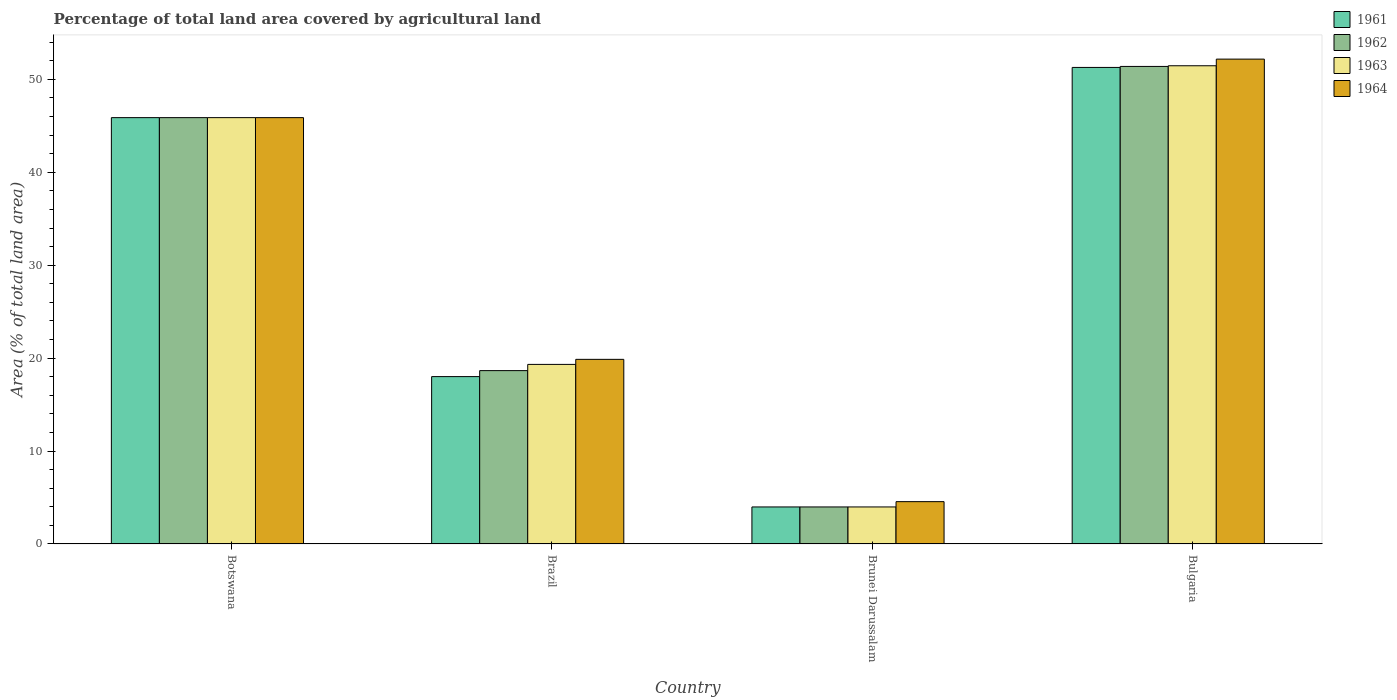Are the number of bars on each tick of the X-axis equal?
Your answer should be compact. Yes. How many bars are there on the 4th tick from the left?
Your answer should be very brief. 4. What is the label of the 3rd group of bars from the left?
Make the answer very short. Brunei Darussalam. What is the percentage of agricultural land in 1962 in Botswana?
Ensure brevity in your answer.  45.88. Across all countries, what is the maximum percentage of agricultural land in 1964?
Ensure brevity in your answer.  52.17. Across all countries, what is the minimum percentage of agricultural land in 1962?
Provide a short and direct response. 3.98. In which country was the percentage of agricultural land in 1961 maximum?
Your response must be concise. Bulgaria. In which country was the percentage of agricultural land in 1962 minimum?
Keep it short and to the point. Brunei Darussalam. What is the total percentage of agricultural land in 1962 in the graph?
Your answer should be compact. 119.9. What is the difference between the percentage of agricultural land in 1964 in Brazil and that in Bulgaria?
Offer a very short reply. -32.31. What is the difference between the percentage of agricultural land in 1964 in Botswana and the percentage of agricultural land in 1963 in Brunei Darussalam?
Offer a very short reply. 41.89. What is the average percentage of agricultural land in 1963 per country?
Your response must be concise. 30.16. What is the difference between the percentage of agricultural land of/in 1964 and percentage of agricultural land of/in 1963 in Bulgaria?
Provide a succinct answer. 0.71. What is the ratio of the percentage of agricultural land in 1963 in Brazil to that in Bulgaria?
Make the answer very short. 0.38. What is the difference between the highest and the second highest percentage of agricultural land in 1961?
Your response must be concise. -33.27. What is the difference between the highest and the lowest percentage of agricultural land in 1963?
Provide a succinct answer. 47.48. Is the sum of the percentage of agricultural land in 1963 in Botswana and Brazil greater than the maximum percentage of agricultural land in 1962 across all countries?
Provide a succinct answer. Yes. What does the 2nd bar from the right in Bulgaria represents?
Your answer should be compact. 1963. How many countries are there in the graph?
Give a very brief answer. 4. What is the difference between two consecutive major ticks on the Y-axis?
Your response must be concise. 10. Does the graph contain any zero values?
Offer a very short reply. No. Does the graph contain grids?
Provide a succinct answer. No. Where does the legend appear in the graph?
Offer a very short reply. Top right. How many legend labels are there?
Provide a short and direct response. 4. How are the legend labels stacked?
Offer a very short reply. Vertical. What is the title of the graph?
Provide a short and direct response. Percentage of total land area covered by agricultural land. Does "2012" appear as one of the legend labels in the graph?
Provide a short and direct response. No. What is the label or title of the X-axis?
Provide a short and direct response. Country. What is the label or title of the Y-axis?
Your answer should be very brief. Area (% of total land area). What is the Area (% of total land area) in 1961 in Botswana?
Make the answer very short. 45.88. What is the Area (% of total land area) of 1962 in Botswana?
Provide a succinct answer. 45.88. What is the Area (% of total land area) of 1963 in Botswana?
Make the answer very short. 45.88. What is the Area (% of total land area) in 1964 in Botswana?
Provide a short and direct response. 45.88. What is the Area (% of total land area) of 1961 in Brazil?
Give a very brief answer. 18.01. What is the Area (% of total land area) in 1962 in Brazil?
Make the answer very short. 18.65. What is the Area (% of total land area) of 1963 in Brazil?
Provide a short and direct response. 19.32. What is the Area (% of total land area) in 1964 in Brazil?
Your answer should be compact. 19.87. What is the Area (% of total land area) in 1961 in Brunei Darussalam?
Provide a short and direct response. 3.98. What is the Area (% of total land area) of 1962 in Brunei Darussalam?
Give a very brief answer. 3.98. What is the Area (% of total land area) in 1963 in Brunei Darussalam?
Your answer should be very brief. 3.98. What is the Area (% of total land area) of 1964 in Brunei Darussalam?
Your answer should be compact. 4.55. What is the Area (% of total land area) in 1961 in Bulgaria?
Give a very brief answer. 51.28. What is the Area (% of total land area) in 1962 in Bulgaria?
Offer a very short reply. 51.39. What is the Area (% of total land area) in 1963 in Bulgaria?
Offer a very short reply. 51.46. What is the Area (% of total land area) in 1964 in Bulgaria?
Ensure brevity in your answer.  52.17. Across all countries, what is the maximum Area (% of total land area) of 1961?
Ensure brevity in your answer.  51.28. Across all countries, what is the maximum Area (% of total land area) in 1962?
Offer a very short reply. 51.39. Across all countries, what is the maximum Area (% of total land area) of 1963?
Your response must be concise. 51.46. Across all countries, what is the maximum Area (% of total land area) of 1964?
Offer a very short reply. 52.17. Across all countries, what is the minimum Area (% of total land area) of 1961?
Your answer should be very brief. 3.98. Across all countries, what is the minimum Area (% of total land area) in 1962?
Offer a very short reply. 3.98. Across all countries, what is the minimum Area (% of total land area) in 1963?
Ensure brevity in your answer.  3.98. Across all countries, what is the minimum Area (% of total land area) in 1964?
Your answer should be very brief. 4.55. What is the total Area (% of total land area) of 1961 in the graph?
Make the answer very short. 119.15. What is the total Area (% of total land area) in 1962 in the graph?
Make the answer very short. 119.9. What is the total Area (% of total land area) in 1963 in the graph?
Your response must be concise. 120.65. What is the total Area (% of total land area) in 1964 in the graph?
Your answer should be compact. 122.47. What is the difference between the Area (% of total land area) of 1961 in Botswana and that in Brazil?
Provide a succinct answer. 27.87. What is the difference between the Area (% of total land area) in 1962 in Botswana and that in Brazil?
Your answer should be very brief. 27.22. What is the difference between the Area (% of total land area) in 1963 in Botswana and that in Brazil?
Offer a terse response. 26.55. What is the difference between the Area (% of total land area) of 1964 in Botswana and that in Brazil?
Provide a succinct answer. 26.01. What is the difference between the Area (% of total land area) of 1961 in Botswana and that in Brunei Darussalam?
Offer a very short reply. 41.89. What is the difference between the Area (% of total land area) of 1962 in Botswana and that in Brunei Darussalam?
Your answer should be compact. 41.89. What is the difference between the Area (% of total land area) in 1963 in Botswana and that in Brunei Darussalam?
Provide a succinct answer. 41.89. What is the difference between the Area (% of total land area) in 1964 in Botswana and that in Brunei Darussalam?
Provide a short and direct response. 41.32. What is the difference between the Area (% of total land area) in 1961 in Botswana and that in Bulgaria?
Provide a short and direct response. -5.4. What is the difference between the Area (% of total land area) of 1962 in Botswana and that in Bulgaria?
Your response must be concise. -5.51. What is the difference between the Area (% of total land area) of 1963 in Botswana and that in Bulgaria?
Give a very brief answer. -5.58. What is the difference between the Area (% of total land area) in 1964 in Botswana and that in Bulgaria?
Provide a short and direct response. -6.3. What is the difference between the Area (% of total land area) of 1961 in Brazil and that in Brunei Darussalam?
Offer a terse response. 14.03. What is the difference between the Area (% of total land area) in 1962 in Brazil and that in Brunei Darussalam?
Your answer should be compact. 14.67. What is the difference between the Area (% of total land area) in 1963 in Brazil and that in Brunei Darussalam?
Provide a short and direct response. 15.34. What is the difference between the Area (% of total land area) of 1964 in Brazil and that in Brunei Darussalam?
Ensure brevity in your answer.  15.31. What is the difference between the Area (% of total land area) in 1961 in Brazil and that in Bulgaria?
Keep it short and to the point. -33.27. What is the difference between the Area (% of total land area) in 1962 in Brazil and that in Bulgaria?
Provide a succinct answer. -32.73. What is the difference between the Area (% of total land area) in 1963 in Brazil and that in Bulgaria?
Your response must be concise. -32.14. What is the difference between the Area (% of total land area) in 1964 in Brazil and that in Bulgaria?
Give a very brief answer. -32.31. What is the difference between the Area (% of total land area) of 1961 in Brunei Darussalam and that in Bulgaria?
Your response must be concise. -47.29. What is the difference between the Area (% of total land area) of 1962 in Brunei Darussalam and that in Bulgaria?
Keep it short and to the point. -47.4. What is the difference between the Area (% of total land area) in 1963 in Brunei Darussalam and that in Bulgaria?
Your answer should be very brief. -47.48. What is the difference between the Area (% of total land area) of 1964 in Brunei Darussalam and that in Bulgaria?
Your response must be concise. -47.62. What is the difference between the Area (% of total land area) in 1961 in Botswana and the Area (% of total land area) in 1962 in Brazil?
Give a very brief answer. 27.22. What is the difference between the Area (% of total land area) of 1961 in Botswana and the Area (% of total land area) of 1963 in Brazil?
Your response must be concise. 26.55. What is the difference between the Area (% of total land area) of 1961 in Botswana and the Area (% of total land area) of 1964 in Brazil?
Your response must be concise. 26.01. What is the difference between the Area (% of total land area) in 1962 in Botswana and the Area (% of total land area) in 1963 in Brazil?
Offer a terse response. 26.55. What is the difference between the Area (% of total land area) of 1962 in Botswana and the Area (% of total land area) of 1964 in Brazil?
Ensure brevity in your answer.  26.01. What is the difference between the Area (% of total land area) in 1963 in Botswana and the Area (% of total land area) in 1964 in Brazil?
Offer a very short reply. 26.01. What is the difference between the Area (% of total land area) in 1961 in Botswana and the Area (% of total land area) in 1962 in Brunei Darussalam?
Keep it short and to the point. 41.89. What is the difference between the Area (% of total land area) of 1961 in Botswana and the Area (% of total land area) of 1963 in Brunei Darussalam?
Your response must be concise. 41.89. What is the difference between the Area (% of total land area) in 1961 in Botswana and the Area (% of total land area) in 1964 in Brunei Darussalam?
Your answer should be compact. 41.32. What is the difference between the Area (% of total land area) of 1962 in Botswana and the Area (% of total land area) of 1963 in Brunei Darussalam?
Provide a short and direct response. 41.89. What is the difference between the Area (% of total land area) in 1962 in Botswana and the Area (% of total land area) in 1964 in Brunei Darussalam?
Make the answer very short. 41.32. What is the difference between the Area (% of total land area) in 1963 in Botswana and the Area (% of total land area) in 1964 in Brunei Darussalam?
Offer a very short reply. 41.32. What is the difference between the Area (% of total land area) in 1961 in Botswana and the Area (% of total land area) in 1962 in Bulgaria?
Provide a succinct answer. -5.51. What is the difference between the Area (% of total land area) of 1961 in Botswana and the Area (% of total land area) of 1963 in Bulgaria?
Offer a very short reply. -5.58. What is the difference between the Area (% of total land area) in 1961 in Botswana and the Area (% of total land area) in 1964 in Bulgaria?
Your answer should be compact. -6.3. What is the difference between the Area (% of total land area) of 1962 in Botswana and the Area (% of total land area) of 1963 in Bulgaria?
Your answer should be very brief. -5.58. What is the difference between the Area (% of total land area) in 1962 in Botswana and the Area (% of total land area) in 1964 in Bulgaria?
Give a very brief answer. -6.3. What is the difference between the Area (% of total land area) of 1963 in Botswana and the Area (% of total land area) of 1964 in Bulgaria?
Give a very brief answer. -6.3. What is the difference between the Area (% of total land area) of 1961 in Brazil and the Area (% of total land area) of 1962 in Brunei Darussalam?
Give a very brief answer. 14.03. What is the difference between the Area (% of total land area) in 1961 in Brazil and the Area (% of total land area) in 1963 in Brunei Darussalam?
Make the answer very short. 14.03. What is the difference between the Area (% of total land area) in 1961 in Brazil and the Area (% of total land area) in 1964 in Brunei Darussalam?
Keep it short and to the point. 13.46. What is the difference between the Area (% of total land area) of 1962 in Brazil and the Area (% of total land area) of 1963 in Brunei Darussalam?
Give a very brief answer. 14.67. What is the difference between the Area (% of total land area) of 1962 in Brazil and the Area (% of total land area) of 1964 in Brunei Darussalam?
Your answer should be very brief. 14.1. What is the difference between the Area (% of total land area) of 1963 in Brazil and the Area (% of total land area) of 1964 in Brunei Darussalam?
Provide a short and direct response. 14.77. What is the difference between the Area (% of total land area) in 1961 in Brazil and the Area (% of total land area) in 1962 in Bulgaria?
Your response must be concise. -33.38. What is the difference between the Area (% of total land area) in 1961 in Brazil and the Area (% of total land area) in 1963 in Bulgaria?
Give a very brief answer. -33.45. What is the difference between the Area (% of total land area) in 1961 in Brazil and the Area (% of total land area) in 1964 in Bulgaria?
Your answer should be compact. -34.16. What is the difference between the Area (% of total land area) in 1962 in Brazil and the Area (% of total land area) in 1963 in Bulgaria?
Ensure brevity in your answer.  -32.81. What is the difference between the Area (% of total land area) of 1962 in Brazil and the Area (% of total land area) of 1964 in Bulgaria?
Provide a short and direct response. -33.52. What is the difference between the Area (% of total land area) in 1963 in Brazil and the Area (% of total land area) in 1964 in Bulgaria?
Give a very brief answer. -32.85. What is the difference between the Area (% of total land area) of 1961 in Brunei Darussalam and the Area (% of total land area) of 1962 in Bulgaria?
Offer a terse response. -47.4. What is the difference between the Area (% of total land area) in 1961 in Brunei Darussalam and the Area (% of total land area) in 1963 in Bulgaria?
Give a very brief answer. -47.48. What is the difference between the Area (% of total land area) of 1961 in Brunei Darussalam and the Area (% of total land area) of 1964 in Bulgaria?
Give a very brief answer. -48.19. What is the difference between the Area (% of total land area) in 1962 in Brunei Darussalam and the Area (% of total land area) in 1963 in Bulgaria?
Offer a very short reply. -47.48. What is the difference between the Area (% of total land area) of 1962 in Brunei Darussalam and the Area (% of total land area) of 1964 in Bulgaria?
Offer a very short reply. -48.19. What is the difference between the Area (% of total land area) of 1963 in Brunei Darussalam and the Area (% of total land area) of 1964 in Bulgaria?
Provide a succinct answer. -48.19. What is the average Area (% of total land area) of 1961 per country?
Give a very brief answer. 29.79. What is the average Area (% of total land area) in 1962 per country?
Give a very brief answer. 29.98. What is the average Area (% of total land area) of 1963 per country?
Your answer should be very brief. 30.16. What is the average Area (% of total land area) of 1964 per country?
Offer a terse response. 30.62. What is the difference between the Area (% of total land area) in 1961 and Area (% of total land area) in 1963 in Botswana?
Provide a short and direct response. 0. What is the difference between the Area (% of total land area) in 1962 and Area (% of total land area) in 1963 in Botswana?
Your answer should be compact. 0. What is the difference between the Area (% of total land area) in 1961 and Area (% of total land area) in 1962 in Brazil?
Offer a very short reply. -0.64. What is the difference between the Area (% of total land area) in 1961 and Area (% of total land area) in 1963 in Brazil?
Your answer should be compact. -1.31. What is the difference between the Area (% of total land area) in 1961 and Area (% of total land area) in 1964 in Brazil?
Offer a terse response. -1.86. What is the difference between the Area (% of total land area) in 1962 and Area (% of total land area) in 1963 in Brazil?
Provide a succinct answer. -0.67. What is the difference between the Area (% of total land area) in 1962 and Area (% of total land area) in 1964 in Brazil?
Your answer should be compact. -1.21. What is the difference between the Area (% of total land area) of 1963 and Area (% of total land area) of 1964 in Brazil?
Offer a terse response. -0.54. What is the difference between the Area (% of total land area) in 1961 and Area (% of total land area) in 1964 in Brunei Darussalam?
Keep it short and to the point. -0.57. What is the difference between the Area (% of total land area) of 1962 and Area (% of total land area) of 1963 in Brunei Darussalam?
Give a very brief answer. 0. What is the difference between the Area (% of total land area) of 1962 and Area (% of total land area) of 1964 in Brunei Darussalam?
Offer a very short reply. -0.57. What is the difference between the Area (% of total land area) in 1963 and Area (% of total land area) in 1964 in Brunei Darussalam?
Make the answer very short. -0.57. What is the difference between the Area (% of total land area) in 1961 and Area (% of total land area) in 1962 in Bulgaria?
Give a very brief answer. -0.11. What is the difference between the Area (% of total land area) in 1961 and Area (% of total land area) in 1963 in Bulgaria?
Your answer should be very brief. -0.18. What is the difference between the Area (% of total land area) of 1961 and Area (% of total land area) of 1964 in Bulgaria?
Your answer should be very brief. -0.89. What is the difference between the Area (% of total land area) of 1962 and Area (% of total land area) of 1963 in Bulgaria?
Offer a terse response. -0.07. What is the difference between the Area (% of total land area) in 1962 and Area (% of total land area) in 1964 in Bulgaria?
Offer a terse response. -0.79. What is the difference between the Area (% of total land area) of 1963 and Area (% of total land area) of 1964 in Bulgaria?
Make the answer very short. -0.71. What is the ratio of the Area (% of total land area) in 1961 in Botswana to that in Brazil?
Your answer should be very brief. 2.55. What is the ratio of the Area (% of total land area) in 1962 in Botswana to that in Brazil?
Offer a terse response. 2.46. What is the ratio of the Area (% of total land area) in 1963 in Botswana to that in Brazil?
Offer a terse response. 2.37. What is the ratio of the Area (% of total land area) in 1964 in Botswana to that in Brazil?
Ensure brevity in your answer.  2.31. What is the ratio of the Area (% of total land area) in 1961 in Botswana to that in Brunei Darussalam?
Give a very brief answer. 11.51. What is the ratio of the Area (% of total land area) in 1962 in Botswana to that in Brunei Darussalam?
Your response must be concise. 11.51. What is the ratio of the Area (% of total land area) in 1963 in Botswana to that in Brunei Darussalam?
Give a very brief answer. 11.51. What is the ratio of the Area (% of total land area) in 1964 in Botswana to that in Brunei Darussalam?
Offer a very short reply. 10.07. What is the ratio of the Area (% of total land area) in 1961 in Botswana to that in Bulgaria?
Provide a short and direct response. 0.89. What is the ratio of the Area (% of total land area) of 1962 in Botswana to that in Bulgaria?
Make the answer very short. 0.89. What is the ratio of the Area (% of total land area) of 1963 in Botswana to that in Bulgaria?
Give a very brief answer. 0.89. What is the ratio of the Area (% of total land area) in 1964 in Botswana to that in Bulgaria?
Your answer should be very brief. 0.88. What is the ratio of the Area (% of total land area) in 1961 in Brazil to that in Brunei Darussalam?
Ensure brevity in your answer.  4.52. What is the ratio of the Area (% of total land area) of 1962 in Brazil to that in Brunei Darussalam?
Keep it short and to the point. 4.68. What is the ratio of the Area (% of total land area) of 1963 in Brazil to that in Brunei Darussalam?
Your response must be concise. 4.85. What is the ratio of the Area (% of total land area) in 1964 in Brazil to that in Brunei Darussalam?
Offer a terse response. 4.36. What is the ratio of the Area (% of total land area) of 1961 in Brazil to that in Bulgaria?
Your response must be concise. 0.35. What is the ratio of the Area (% of total land area) in 1962 in Brazil to that in Bulgaria?
Your answer should be very brief. 0.36. What is the ratio of the Area (% of total land area) of 1963 in Brazil to that in Bulgaria?
Give a very brief answer. 0.38. What is the ratio of the Area (% of total land area) of 1964 in Brazil to that in Bulgaria?
Provide a short and direct response. 0.38. What is the ratio of the Area (% of total land area) in 1961 in Brunei Darussalam to that in Bulgaria?
Give a very brief answer. 0.08. What is the ratio of the Area (% of total land area) in 1962 in Brunei Darussalam to that in Bulgaria?
Provide a succinct answer. 0.08. What is the ratio of the Area (% of total land area) of 1963 in Brunei Darussalam to that in Bulgaria?
Offer a terse response. 0.08. What is the ratio of the Area (% of total land area) of 1964 in Brunei Darussalam to that in Bulgaria?
Provide a short and direct response. 0.09. What is the difference between the highest and the second highest Area (% of total land area) of 1961?
Your response must be concise. 5.4. What is the difference between the highest and the second highest Area (% of total land area) of 1962?
Provide a short and direct response. 5.51. What is the difference between the highest and the second highest Area (% of total land area) of 1963?
Make the answer very short. 5.58. What is the difference between the highest and the second highest Area (% of total land area) of 1964?
Keep it short and to the point. 6.3. What is the difference between the highest and the lowest Area (% of total land area) in 1961?
Ensure brevity in your answer.  47.29. What is the difference between the highest and the lowest Area (% of total land area) in 1962?
Offer a terse response. 47.4. What is the difference between the highest and the lowest Area (% of total land area) of 1963?
Offer a very short reply. 47.48. What is the difference between the highest and the lowest Area (% of total land area) in 1964?
Give a very brief answer. 47.62. 